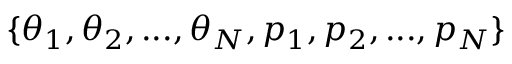<formula> <loc_0><loc_0><loc_500><loc_500>\{ \theta _ { 1 } , \theta _ { 2 } , \dots , \theta _ { N } , p _ { 1 } , p _ { 2 } , \dots , p _ { N } \}</formula> 